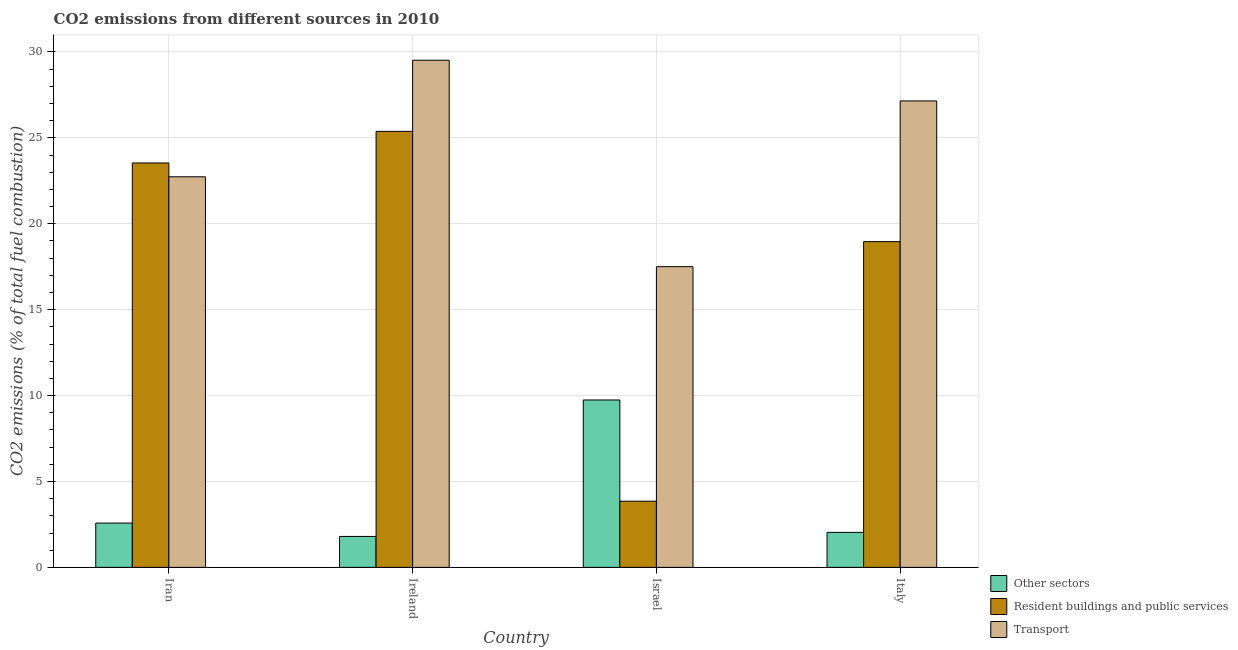How many groups of bars are there?
Keep it short and to the point. 4. What is the label of the 1st group of bars from the left?
Give a very brief answer. Iran. What is the percentage of co2 emissions from transport in Ireland?
Provide a succinct answer. 29.52. Across all countries, what is the maximum percentage of co2 emissions from resident buildings and public services?
Make the answer very short. 25.38. Across all countries, what is the minimum percentage of co2 emissions from other sectors?
Offer a very short reply. 1.8. In which country was the percentage of co2 emissions from resident buildings and public services maximum?
Keep it short and to the point. Ireland. In which country was the percentage of co2 emissions from transport minimum?
Your response must be concise. Israel. What is the total percentage of co2 emissions from other sectors in the graph?
Your response must be concise. 16.16. What is the difference between the percentage of co2 emissions from other sectors in Israel and that in Italy?
Your answer should be compact. 7.71. What is the difference between the percentage of co2 emissions from resident buildings and public services in Iran and the percentage of co2 emissions from transport in Italy?
Your answer should be very brief. -3.61. What is the average percentage of co2 emissions from other sectors per country?
Keep it short and to the point. 4.04. What is the difference between the percentage of co2 emissions from resident buildings and public services and percentage of co2 emissions from transport in Ireland?
Provide a succinct answer. -4.14. In how many countries, is the percentage of co2 emissions from other sectors greater than 18 %?
Provide a succinct answer. 0. What is the ratio of the percentage of co2 emissions from other sectors in Iran to that in Ireland?
Give a very brief answer. 1.43. Is the difference between the percentage of co2 emissions from resident buildings and public services in Ireland and Italy greater than the difference between the percentage of co2 emissions from other sectors in Ireland and Italy?
Give a very brief answer. Yes. What is the difference between the highest and the second highest percentage of co2 emissions from transport?
Provide a short and direct response. 2.37. What is the difference between the highest and the lowest percentage of co2 emissions from transport?
Keep it short and to the point. 12.02. In how many countries, is the percentage of co2 emissions from resident buildings and public services greater than the average percentage of co2 emissions from resident buildings and public services taken over all countries?
Your answer should be compact. 3. Is the sum of the percentage of co2 emissions from resident buildings and public services in Iran and Ireland greater than the maximum percentage of co2 emissions from other sectors across all countries?
Offer a terse response. Yes. What does the 3rd bar from the left in Ireland represents?
Offer a very short reply. Transport. What does the 3rd bar from the right in Ireland represents?
Your response must be concise. Other sectors. Is it the case that in every country, the sum of the percentage of co2 emissions from other sectors and percentage of co2 emissions from resident buildings and public services is greater than the percentage of co2 emissions from transport?
Provide a short and direct response. No. What is the difference between two consecutive major ticks on the Y-axis?
Your answer should be very brief. 5. Does the graph contain any zero values?
Offer a very short reply. No. Does the graph contain grids?
Your response must be concise. Yes. Where does the legend appear in the graph?
Offer a terse response. Bottom right. How many legend labels are there?
Make the answer very short. 3. How are the legend labels stacked?
Offer a very short reply. Vertical. What is the title of the graph?
Ensure brevity in your answer.  CO2 emissions from different sources in 2010. Does "Czech Republic" appear as one of the legend labels in the graph?
Ensure brevity in your answer.  No. What is the label or title of the X-axis?
Keep it short and to the point. Country. What is the label or title of the Y-axis?
Your answer should be compact. CO2 emissions (% of total fuel combustion). What is the CO2 emissions (% of total fuel combustion) of Other sectors in Iran?
Your response must be concise. 2.58. What is the CO2 emissions (% of total fuel combustion) in Resident buildings and public services in Iran?
Make the answer very short. 23.54. What is the CO2 emissions (% of total fuel combustion) of Transport in Iran?
Your response must be concise. 22.73. What is the CO2 emissions (% of total fuel combustion) of Other sectors in Ireland?
Offer a very short reply. 1.8. What is the CO2 emissions (% of total fuel combustion) of Resident buildings and public services in Ireland?
Your answer should be very brief. 25.38. What is the CO2 emissions (% of total fuel combustion) of Transport in Ireland?
Your answer should be compact. 29.52. What is the CO2 emissions (% of total fuel combustion) in Other sectors in Israel?
Give a very brief answer. 9.74. What is the CO2 emissions (% of total fuel combustion) of Resident buildings and public services in Israel?
Make the answer very short. 3.85. What is the CO2 emissions (% of total fuel combustion) in Transport in Israel?
Give a very brief answer. 17.5. What is the CO2 emissions (% of total fuel combustion) of Other sectors in Italy?
Provide a short and direct response. 2.04. What is the CO2 emissions (% of total fuel combustion) in Resident buildings and public services in Italy?
Your answer should be very brief. 18.96. What is the CO2 emissions (% of total fuel combustion) in Transport in Italy?
Keep it short and to the point. 27.15. Across all countries, what is the maximum CO2 emissions (% of total fuel combustion) of Other sectors?
Give a very brief answer. 9.74. Across all countries, what is the maximum CO2 emissions (% of total fuel combustion) in Resident buildings and public services?
Your answer should be compact. 25.38. Across all countries, what is the maximum CO2 emissions (% of total fuel combustion) in Transport?
Your response must be concise. 29.52. Across all countries, what is the minimum CO2 emissions (% of total fuel combustion) in Other sectors?
Provide a short and direct response. 1.8. Across all countries, what is the minimum CO2 emissions (% of total fuel combustion) in Resident buildings and public services?
Your answer should be very brief. 3.85. Across all countries, what is the minimum CO2 emissions (% of total fuel combustion) in Transport?
Your response must be concise. 17.5. What is the total CO2 emissions (% of total fuel combustion) of Other sectors in the graph?
Keep it short and to the point. 16.16. What is the total CO2 emissions (% of total fuel combustion) of Resident buildings and public services in the graph?
Offer a very short reply. 71.73. What is the total CO2 emissions (% of total fuel combustion) of Transport in the graph?
Keep it short and to the point. 96.91. What is the difference between the CO2 emissions (% of total fuel combustion) in Other sectors in Iran and that in Ireland?
Provide a short and direct response. 0.78. What is the difference between the CO2 emissions (% of total fuel combustion) in Resident buildings and public services in Iran and that in Ireland?
Ensure brevity in your answer.  -1.84. What is the difference between the CO2 emissions (% of total fuel combustion) of Transport in Iran and that in Ireland?
Offer a terse response. -6.78. What is the difference between the CO2 emissions (% of total fuel combustion) in Other sectors in Iran and that in Israel?
Ensure brevity in your answer.  -7.16. What is the difference between the CO2 emissions (% of total fuel combustion) of Resident buildings and public services in Iran and that in Israel?
Give a very brief answer. 19.69. What is the difference between the CO2 emissions (% of total fuel combustion) in Transport in Iran and that in Israel?
Your response must be concise. 5.23. What is the difference between the CO2 emissions (% of total fuel combustion) in Other sectors in Iran and that in Italy?
Provide a succinct answer. 0.54. What is the difference between the CO2 emissions (% of total fuel combustion) in Resident buildings and public services in Iran and that in Italy?
Your response must be concise. 4.58. What is the difference between the CO2 emissions (% of total fuel combustion) of Transport in Iran and that in Italy?
Ensure brevity in your answer.  -4.42. What is the difference between the CO2 emissions (% of total fuel combustion) of Other sectors in Ireland and that in Israel?
Offer a very short reply. -7.94. What is the difference between the CO2 emissions (% of total fuel combustion) in Resident buildings and public services in Ireland and that in Israel?
Offer a terse response. 21.53. What is the difference between the CO2 emissions (% of total fuel combustion) of Transport in Ireland and that in Israel?
Provide a succinct answer. 12.02. What is the difference between the CO2 emissions (% of total fuel combustion) in Other sectors in Ireland and that in Italy?
Your answer should be very brief. -0.24. What is the difference between the CO2 emissions (% of total fuel combustion) in Resident buildings and public services in Ireland and that in Italy?
Offer a very short reply. 6.42. What is the difference between the CO2 emissions (% of total fuel combustion) of Transport in Ireland and that in Italy?
Your answer should be very brief. 2.37. What is the difference between the CO2 emissions (% of total fuel combustion) in Other sectors in Israel and that in Italy?
Your response must be concise. 7.71. What is the difference between the CO2 emissions (% of total fuel combustion) in Resident buildings and public services in Israel and that in Italy?
Provide a succinct answer. -15.11. What is the difference between the CO2 emissions (% of total fuel combustion) in Transport in Israel and that in Italy?
Make the answer very short. -9.65. What is the difference between the CO2 emissions (% of total fuel combustion) of Other sectors in Iran and the CO2 emissions (% of total fuel combustion) of Resident buildings and public services in Ireland?
Your response must be concise. -22.8. What is the difference between the CO2 emissions (% of total fuel combustion) of Other sectors in Iran and the CO2 emissions (% of total fuel combustion) of Transport in Ireland?
Offer a very short reply. -26.94. What is the difference between the CO2 emissions (% of total fuel combustion) of Resident buildings and public services in Iran and the CO2 emissions (% of total fuel combustion) of Transport in Ireland?
Offer a terse response. -5.98. What is the difference between the CO2 emissions (% of total fuel combustion) in Other sectors in Iran and the CO2 emissions (% of total fuel combustion) in Resident buildings and public services in Israel?
Provide a succinct answer. -1.27. What is the difference between the CO2 emissions (% of total fuel combustion) in Other sectors in Iran and the CO2 emissions (% of total fuel combustion) in Transport in Israel?
Provide a succinct answer. -14.92. What is the difference between the CO2 emissions (% of total fuel combustion) of Resident buildings and public services in Iran and the CO2 emissions (% of total fuel combustion) of Transport in Israel?
Ensure brevity in your answer.  6.04. What is the difference between the CO2 emissions (% of total fuel combustion) of Other sectors in Iran and the CO2 emissions (% of total fuel combustion) of Resident buildings and public services in Italy?
Give a very brief answer. -16.38. What is the difference between the CO2 emissions (% of total fuel combustion) of Other sectors in Iran and the CO2 emissions (% of total fuel combustion) of Transport in Italy?
Provide a short and direct response. -24.57. What is the difference between the CO2 emissions (% of total fuel combustion) of Resident buildings and public services in Iran and the CO2 emissions (% of total fuel combustion) of Transport in Italy?
Give a very brief answer. -3.61. What is the difference between the CO2 emissions (% of total fuel combustion) of Other sectors in Ireland and the CO2 emissions (% of total fuel combustion) of Resident buildings and public services in Israel?
Give a very brief answer. -2.05. What is the difference between the CO2 emissions (% of total fuel combustion) of Other sectors in Ireland and the CO2 emissions (% of total fuel combustion) of Transport in Israel?
Keep it short and to the point. -15.7. What is the difference between the CO2 emissions (% of total fuel combustion) of Resident buildings and public services in Ireland and the CO2 emissions (% of total fuel combustion) of Transport in Israel?
Your answer should be compact. 7.88. What is the difference between the CO2 emissions (% of total fuel combustion) in Other sectors in Ireland and the CO2 emissions (% of total fuel combustion) in Resident buildings and public services in Italy?
Offer a very short reply. -17.16. What is the difference between the CO2 emissions (% of total fuel combustion) in Other sectors in Ireland and the CO2 emissions (% of total fuel combustion) in Transport in Italy?
Your answer should be very brief. -25.35. What is the difference between the CO2 emissions (% of total fuel combustion) in Resident buildings and public services in Ireland and the CO2 emissions (% of total fuel combustion) in Transport in Italy?
Offer a terse response. -1.77. What is the difference between the CO2 emissions (% of total fuel combustion) of Other sectors in Israel and the CO2 emissions (% of total fuel combustion) of Resident buildings and public services in Italy?
Offer a very short reply. -9.22. What is the difference between the CO2 emissions (% of total fuel combustion) in Other sectors in Israel and the CO2 emissions (% of total fuel combustion) in Transport in Italy?
Offer a terse response. -17.41. What is the difference between the CO2 emissions (% of total fuel combustion) in Resident buildings and public services in Israel and the CO2 emissions (% of total fuel combustion) in Transport in Italy?
Your response must be concise. -23.3. What is the average CO2 emissions (% of total fuel combustion) of Other sectors per country?
Your answer should be compact. 4.04. What is the average CO2 emissions (% of total fuel combustion) of Resident buildings and public services per country?
Give a very brief answer. 17.93. What is the average CO2 emissions (% of total fuel combustion) of Transport per country?
Offer a very short reply. 24.23. What is the difference between the CO2 emissions (% of total fuel combustion) in Other sectors and CO2 emissions (% of total fuel combustion) in Resident buildings and public services in Iran?
Keep it short and to the point. -20.96. What is the difference between the CO2 emissions (% of total fuel combustion) in Other sectors and CO2 emissions (% of total fuel combustion) in Transport in Iran?
Your answer should be very brief. -20.16. What is the difference between the CO2 emissions (% of total fuel combustion) of Resident buildings and public services and CO2 emissions (% of total fuel combustion) of Transport in Iran?
Provide a short and direct response. 0.8. What is the difference between the CO2 emissions (% of total fuel combustion) in Other sectors and CO2 emissions (% of total fuel combustion) in Resident buildings and public services in Ireland?
Ensure brevity in your answer.  -23.58. What is the difference between the CO2 emissions (% of total fuel combustion) of Other sectors and CO2 emissions (% of total fuel combustion) of Transport in Ireland?
Offer a very short reply. -27.72. What is the difference between the CO2 emissions (% of total fuel combustion) in Resident buildings and public services and CO2 emissions (% of total fuel combustion) in Transport in Ireland?
Keep it short and to the point. -4.14. What is the difference between the CO2 emissions (% of total fuel combustion) in Other sectors and CO2 emissions (% of total fuel combustion) in Resident buildings and public services in Israel?
Ensure brevity in your answer.  5.89. What is the difference between the CO2 emissions (% of total fuel combustion) of Other sectors and CO2 emissions (% of total fuel combustion) of Transport in Israel?
Give a very brief answer. -7.76. What is the difference between the CO2 emissions (% of total fuel combustion) in Resident buildings and public services and CO2 emissions (% of total fuel combustion) in Transport in Israel?
Give a very brief answer. -13.65. What is the difference between the CO2 emissions (% of total fuel combustion) of Other sectors and CO2 emissions (% of total fuel combustion) of Resident buildings and public services in Italy?
Provide a short and direct response. -16.92. What is the difference between the CO2 emissions (% of total fuel combustion) in Other sectors and CO2 emissions (% of total fuel combustion) in Transport in Italy?
Offer a very short reply. -25.11. What is the difference between the CO2 emissions (% of total fuel combustion) in Resident buildings and public services and CO2 emissions (% of total fuel combustion) in Transport in Italy?
Your response must be concise. -8.19. What is the ratio of the CO2 emissions (% of total fuel combustion) of Other sectors in Iran to that in Ireland?
Provide a short and direct response. 1.43. What is the ratio of the CO2 emissions (% of total fuel combustion) in Resident buildings and public services in Iran to that in Ireland?
Offer a very short reply. 0.93. What is the ratio of the CO2 emissions (% of total fuel combustion) in Transport in Iran to that in Ireland?
Ensure brevity in your answer.  0.77. What is the ratio of the CO2 emissions (% of total fuel combustion) in Other sectors in Iran to that in Israel?
Keep it short and to the point. 0.26. What is the ratio of the CO2 emissions (% of total fuel combustion) of Resident buildings and public services in Iran to that in Israel?
Offer a very short reply. 6.11. What is the ratio of the CO2 emissions (% of total fuel combustion) in Transport in Iran to that in Israel?
Keep it short and to the point. 1.3. What is the ratio of the CO2 emissions (% of total fuel combustion) of Other sectors in Iran to that in Italy?
Keep it short and to the point. 1.27. What is the ratio of the CO2 emissions (% of total fuel combustion) of Resident buildings and public services in Iran to that in Italy?
Offer a very short reply. 1.24. What is the ratio of the CO2 emissions (% of total fuel combustion) in Transport in Iran to that in Italy?
Your answer should be compact. 0.84. What is the ratio of the CO2 emissions (% of total fuel combustion) in Other sectors in Ireland to that in Israel?
Offer a terse response. 0.18. What is the ratio of the CO2 emissions (% of total fuel combustion) in Resident buildings and public services in Ireland to that in Israel?
Provide a succinct answer. 6.59. What is the ratio of the CO2 emissions (% of total fuel combustion) in Transport in Ireland to that in Israel?
Offer a very short reply. 1.69. What is the ratio of the CO2 emissions (% of total fuel combustion) of Other sectors in Ireland to that in Italy?
Your answer should be very brief. 0.88. What is the ratio of the CO2 emissions (% of total fuel combustion) of Resident buildings and public services in Ireland to that in Italy?
Give a very brief answer. 1.34. What is the ratio of the CO2 emissions (% of total fuel combustion) in Transport in Ireland to that in Italy?
Offer a terse response. 1.09. What is the ratio of the CO2 emissions (% of total fuel combustion) in Other sectors in Israel to that in Italy?
Give a very brief answer. 4.78. What is the ratio of the CO2 emissions (% of total fuel combustion) of Resident buildings and public services in Israel to that in Italy?
Provide a short and direct response. 0.2. What is the ratio of the CO2 emissions (% of total fuel combustion) of Transport in Israel to that in Italy?
Your answer should be compact. 0.64. What is the difference between the highest and the second highest CO2 emissions (% of total fuel combustion) in Other sectors?
Provide a succinct answer. 7.16. What is the difference between the highest and the second highest CO2 emissions (% of total fuel combustion) in Resident buildings and public services?
Provide a short and direct response. 1.84. What is the difference between the highest and the second highest CO2 emissions (% of total fuel combustion) of Transport?
Provide a short and direct response. 2.37. What is the difference between the highest and the lowest CO2 emissions (% of total fuel combustion) of Other sectors?
Provide a succinct answer. 7.94. What is the difference between the highest and the lowest CO2 emissions (% of total fuel combustion) of Resident buildings and public services?
Offer a terse response. 21.53. What is the difference between the highest and the lowest CO2 emissions (% of total fuel combustion) in Transport?
Offer a very short reply. 12.02. 